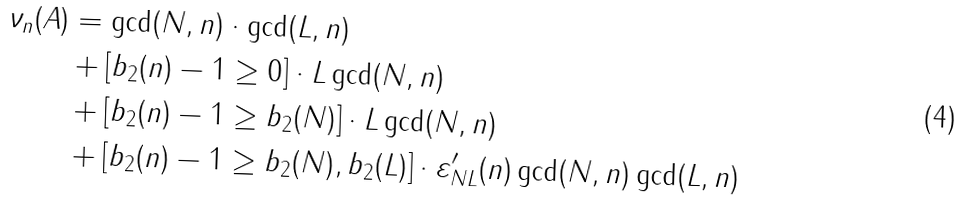<formula> <loc_0><loc_0><loc_500><loc_500>\nu _ { n } ( A ) & = \gcd ( N , n ) \cdot \gcd ( L , n ) \\ & + [ b _ { 2 } ( n ) - 1 \geq 0 ] \cdot L \gcd ( N , n ) \\ & + [ b _ { 2 } ( n ) - 1 \geq b _ { 2 } ( N ) ] \cdot L \gcd ( N , n ) \\ & + [ b _ { 2 } ( n ) - 1 \geq b _ { 2 } ( N ) , b _ { 2 } ( L ) ] \cdot \varepsilon _ { N L } ^ { \prime } ( n ) \gcd ( N , n ) \gcd ( L , n )</formula> 